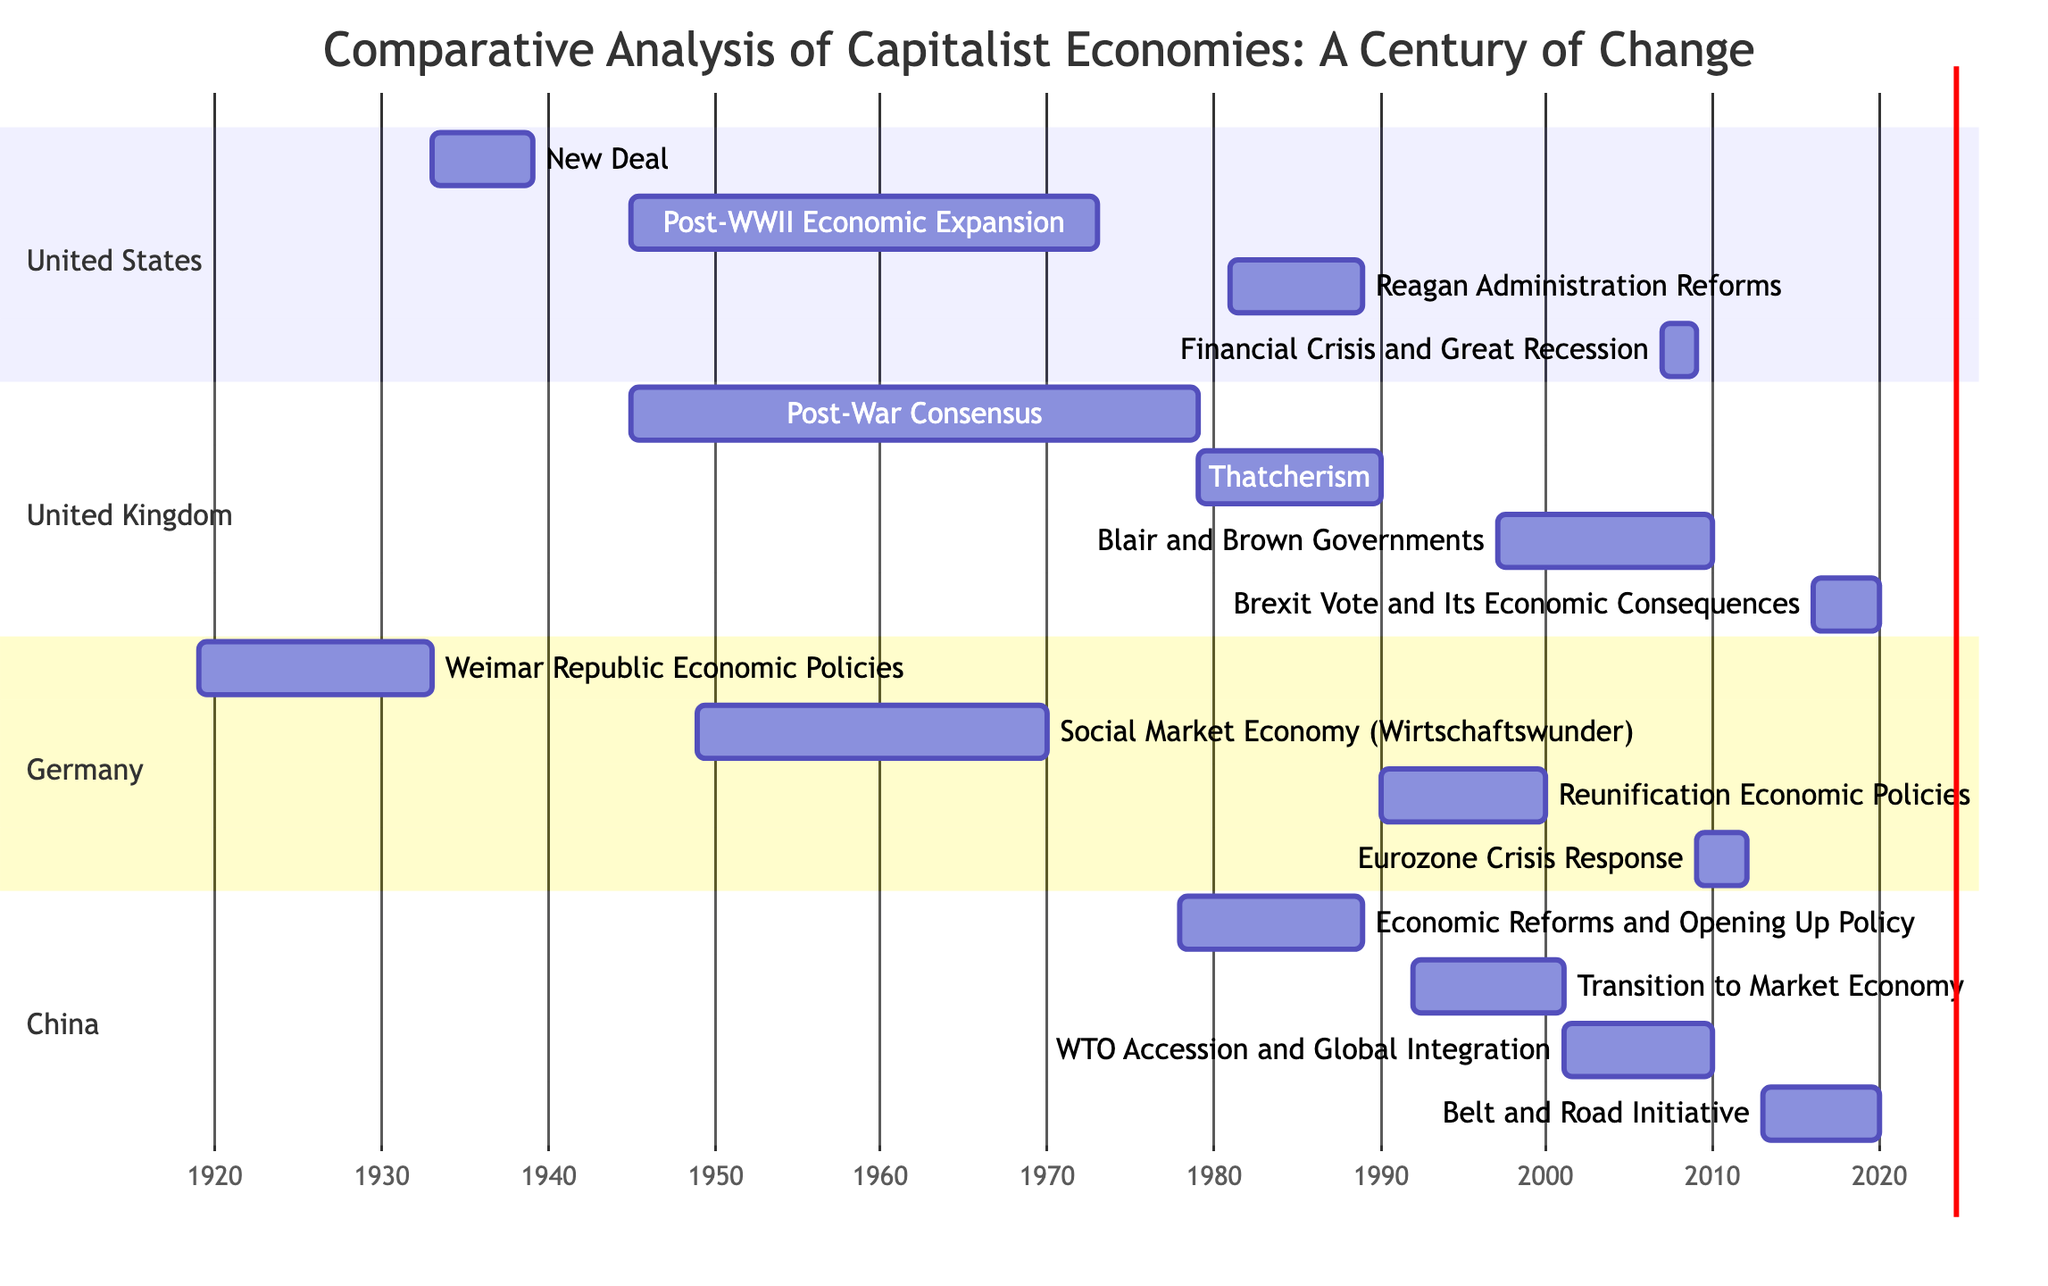What is the duration of the New Deal in the United States? The New Deal started in 1933 and ended in 1939. To calculate the duration, subtract the starting year from the ending year: 1939 - 1933 = 6 years.
Answer: 6 years Which economic reform in the UK lasted the longest? Examining the UK section, the Post-War Consensus ran from 1945 to 1979, which is a total of 34 years. This is longer than any other reform in the UK section.
Answer: Post-War Consensus When did Germany implement the Weimar Republic Economic Policies? The diagram shows that the Weimar Republic Economic Policies were active from 1919 to 1933. This timeframe indicates the starting year as 1919 and ending year as 1933, with no other indications for alterations in dates.
Answer: 1919 What economic policy in China directly followed the Economic Reforms and Opening Up Policy? In the China section, the sequence is clear: the Economic Reforms and Opening Up Policy lasted from 1978 to 1989, followed immediately by the Transition to Market Economy, which began in 1992. This indicates a logical progression of policies.
Answer: Transition to Market Economy How many years did the Eurozone Crisis Response in Germany last? The Eurozone Crisis Response is recorded on the diagram as lasting from 2009 to 2012. To determine the duration, the calculation is 2012 - 2009 = 3 years. Therefore, it lasted for a total of 3 years.
Answer: 3 years Which country had economic reforms during the 1990s that included reunification policies? Specific to the diagram, Germany has a task titled Reunification Economic Policies that explicitly states its duration from 1990 to 2000, directly indicating these reforms occurred during the 1990s.
Answer: Germany What was the primary economic event in the United States during 2007-2009? In the United States section, there is a clear identification of the Financial Crisis and Great Recession labeled with its timeframe of 2007 to 2009. This indicates that these were the significant economic events during this period.
Answer: Financial Crisis and Great Recession Which two countries experienced significant economic reforms in the same decade (2000s)? Looking at the diagram, both Germany and China had economic activities: Germany’s Eurozone Crisis Response from 2009 to 2012, and China’s WTO Accession and Global Integration from 2001 to 2010. The overlapping years indicate both countries had reforms during this decade.
Answer: Germany and China 